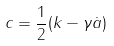<formula> <loc_0><loc_0><loc_500><loc_500>c = \frac { 1 } { 2 } ( k - \gamma \dot { a } )</formula> 